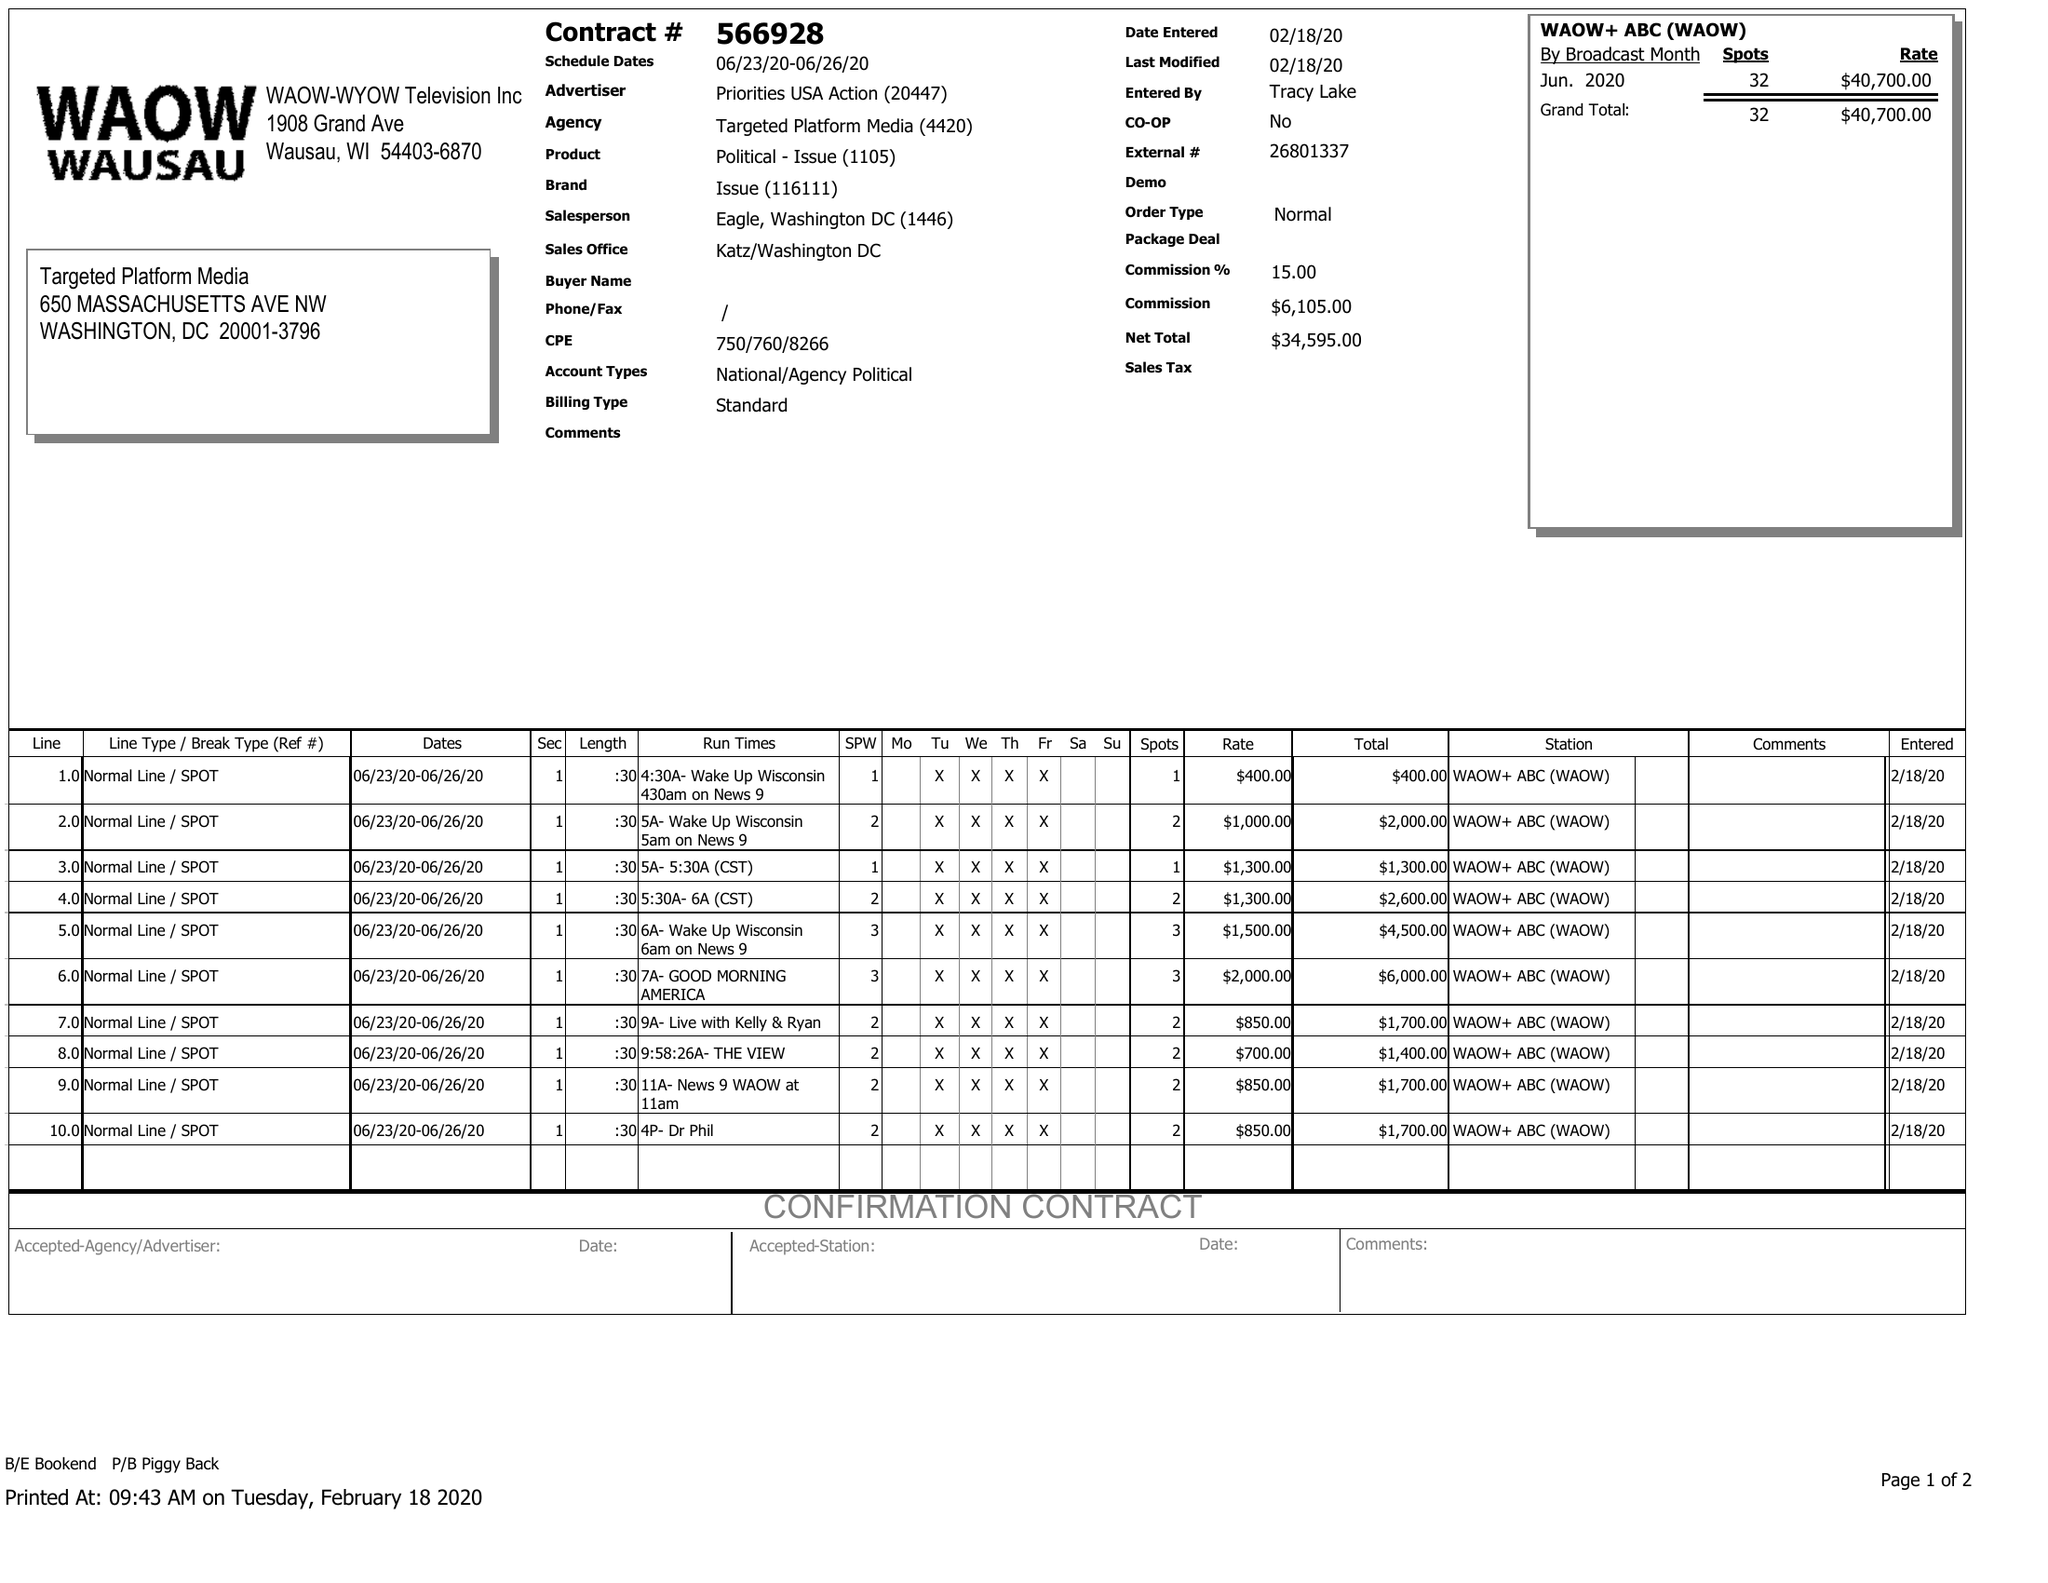What is the value for the flight_from?
Answer the question using a single word or phrase. 06/23/20 